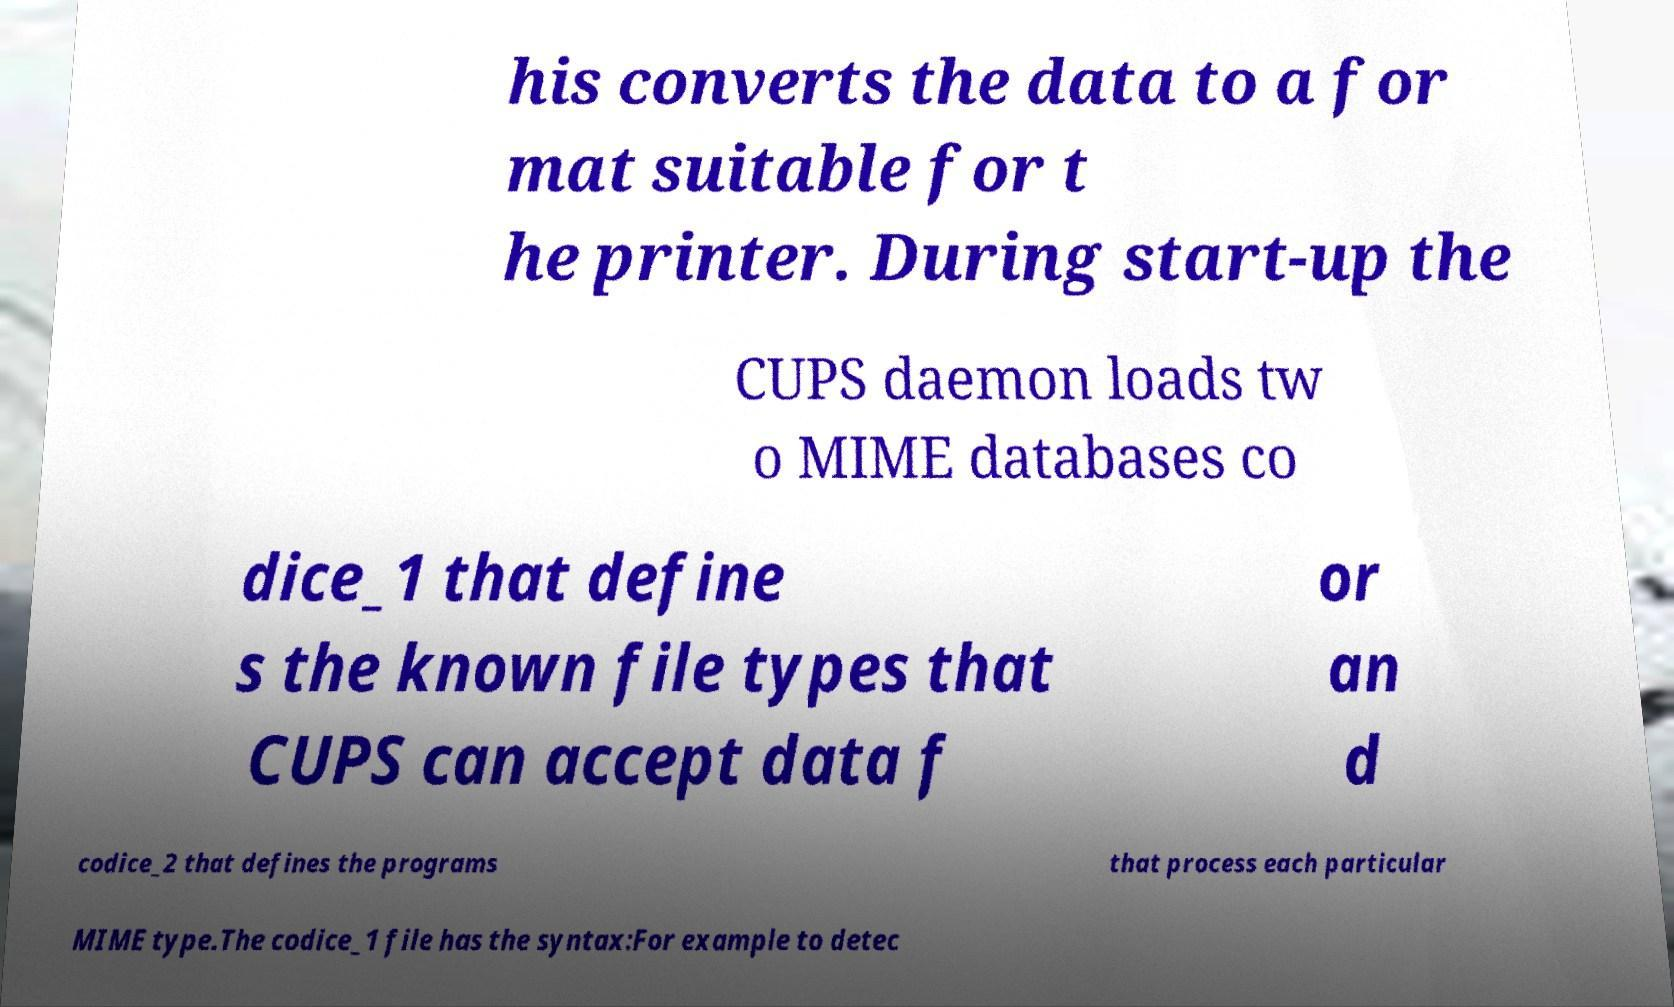Please read and relay the text visible in this image. What does it say? his converts the data to a for mat suitable for t he printer. During start-up the CUPS daemon loads tw o MIME databases co dice_1 that define s the known file types that CUPS can accept data f or an d codice_2 that defines the programs that process each particular MIME type.The codice_1 file has the syntax:For example to detec 